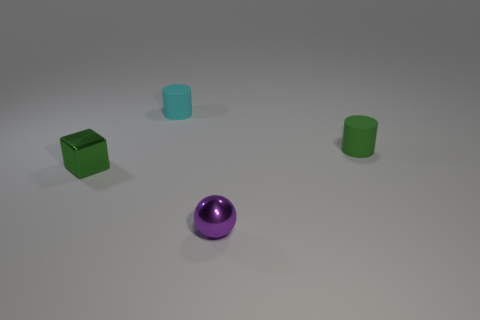What material is the sphere that is the same size as the cyan rubber cylinder?
Ensure brevity in your answer.  Metal. How big is the cylinder left of the rubber object to the right of the cylinder on the left side of the green matte cylinder?
Provide a succinct answer. Small. Do the matte cylinder that is in front of the small cyan cylinder and the cube that is in front of the tiny cyan rubber thing have the same color?
Ensure brevity in your answer.  Yes. What number of red objects are either blocks or cylinders?
Provide a short and direct response. 0. How many shiny cubes have the same size as the cyan rubber cylinder?
Ensure brevity in your answer.  1. Are the cylinder that is left of the purple metal sphere and the green cylinder made of the same material?
Ensure brevity in your answer.  Yes. Are there any small green cubes that are to the right of the rubber object on the left side of the tiny sphere?
Give a very brief answer. No. Is the number of cyan things behind the tiny cyan object greater than the number of tiny cyan matte things left of the tiny green matte object?
Make the answer very short. No. There is a tiny purple thing that is the same material as the small block; what is its shape?
Ensure brevity in your answer.  Sphere. Are there more small metallic things that are to the right of the tiny cube than tiny brown metallic objects?
Provide a short and direct response. Yes. 